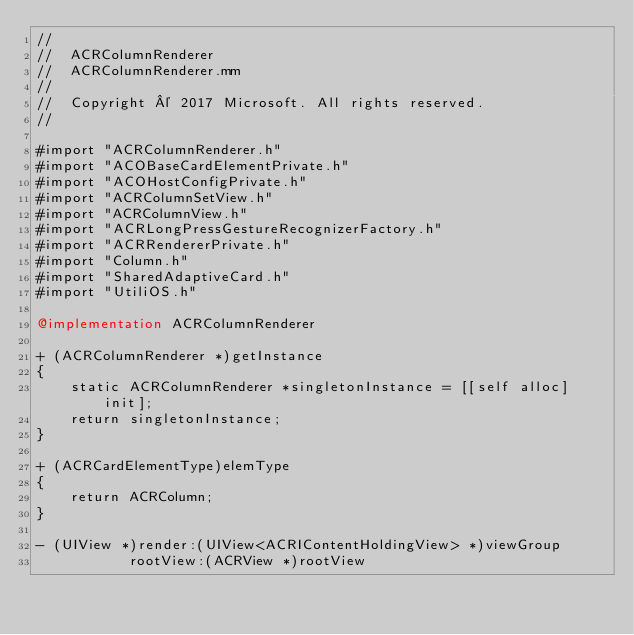Convert code to text. <code><loc_0><loc_0><loc_500><loc_500><_ObjectiveC_>//
//  ACRColumnRenderer
//  ACRColumnRenderer.mm
//
//  Copyright © 2017 Microsoft. All rights reserved.
//

#import "ACRColumnRenderer.h"
#import "ACOBaseCardElementPrivate.h"
#import "ACOHostConfigPrivate.h"
#import "ACRColumnSetView.h"
#import "ACRColumnView.h"
#import "ACRLongPressGestureRecognizerFactory.h"
#import "ACRRendererPrivate.h"
#import "Column.h"
#import "SharedAdaptiveCard.h"
#import "UtiliOS.h"

@implementation ACRColumnRenderer

+ (ACRColumnRenderer *)getInstance
{
    static ACRColumnRenderer *singletonInstance = [[self alloc] init];
    return singletonInstance;
}

+ (ACRCardElementType)elemType
{
    return ACRColumn;
}

- (UIView *)render:(UIView<ACRIContentHoldingView> *)viewGroup
           rootView:(ACRView *)rootView</code> 